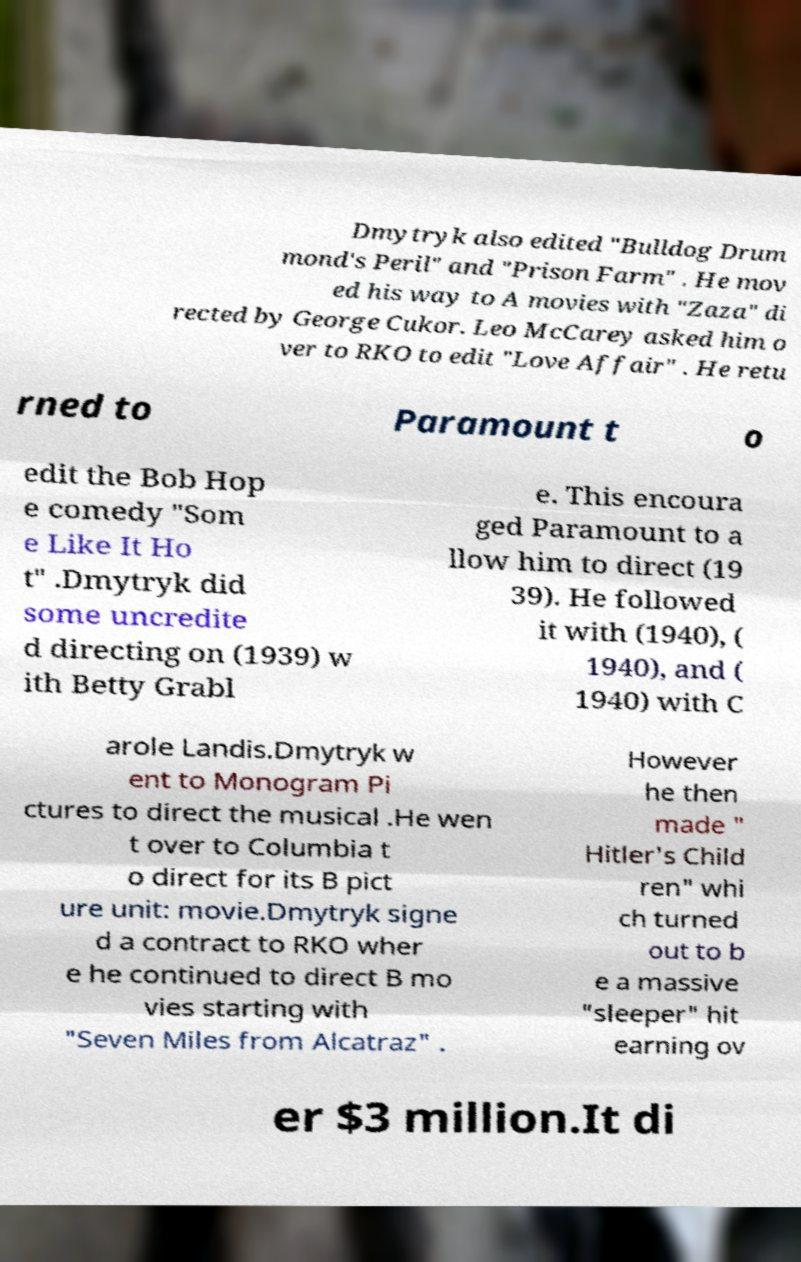Please identify and transcribe the text found in this image. Dmytryk also edited "Bulldog Drum mond's Peril" and "Prison Farm" . He mov ed his way to A movies with "Zaza" di rected by George Cukor. Leo McCarey asked him o ver to RKO to edit "Love Affair" . He retu rned to Paramount t o edit the Bob Hop e comedy "Som e Like It Ho t" .Dmytryk did some uncredite d directing on (1939) w ith Betty Grabl e. This encoura ged Paramount to a llow him to direct (19 39). He followed it with (1940), ( 1940), and ( 1940) with C arole Landis.Dmytryk w ent to Monogram Pi ctures to direct the musical .He wen t over to Columbia t o direct for its B pict ure unit: movie.Dmytryk signe d a contract to RKO wher e he continued to direct B mo vies starting with "Seven Miles from Alcatraz" . However he then made " Hitler's Child ren" whi ch turned out to b e a massive "sleeper" hit earning ov er $3 million.It di 